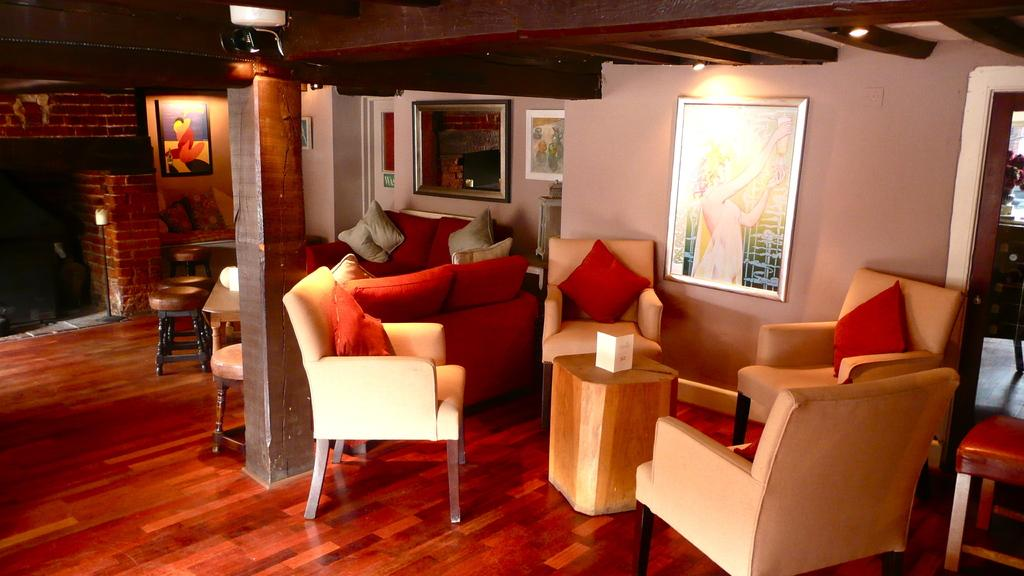What type of furniture is present in the image? There are sofa chairs in the image. What can be seen on the wall in the image? There is an image frame on the wall in the image. Are there any pets visible in the image? There is no mention of pets in the provided facts, so we cannot determine if any are present in the image. 